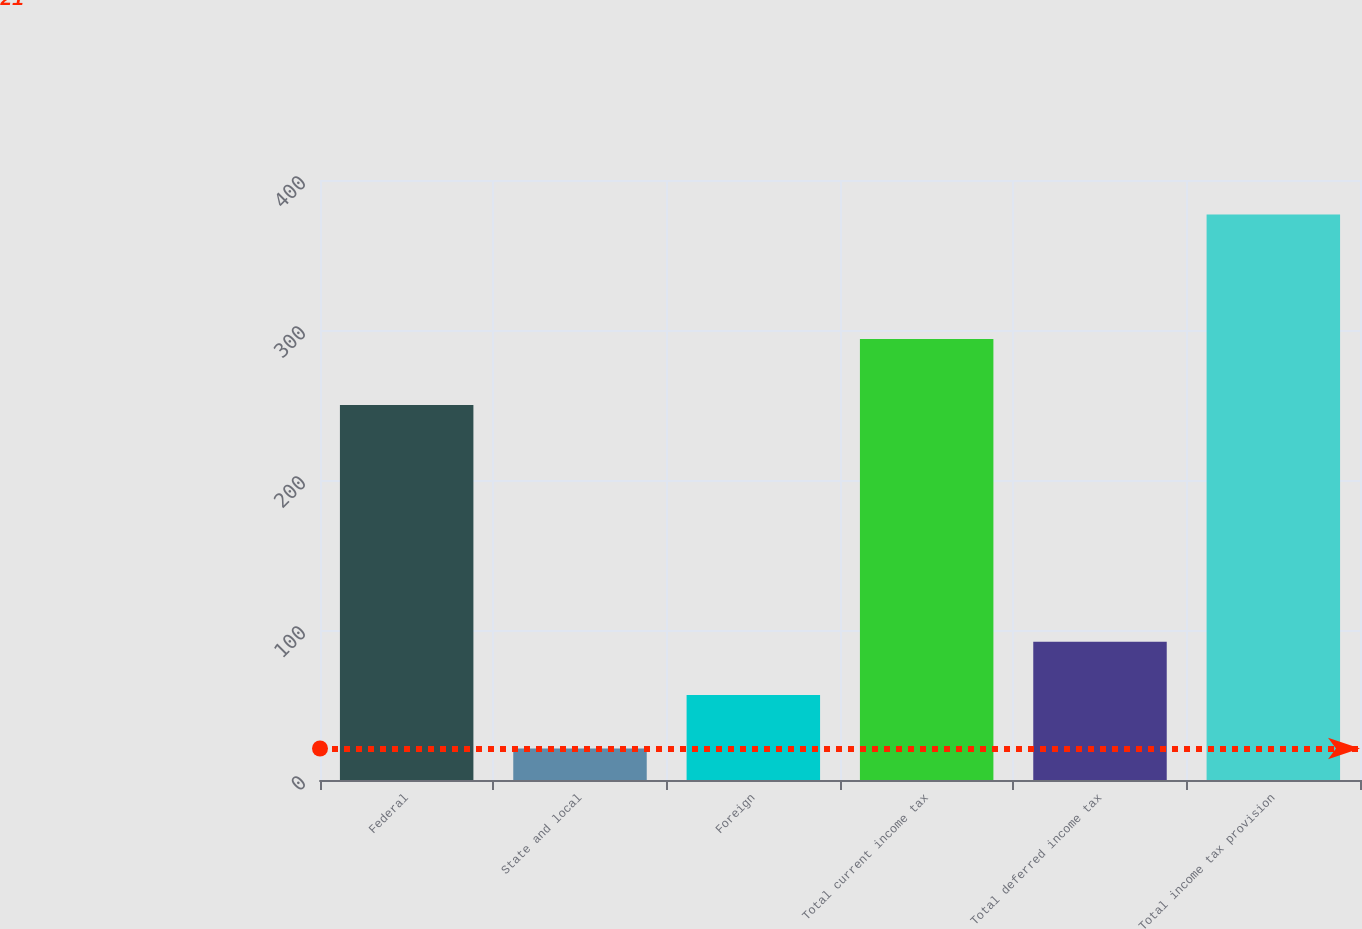Convert chart. <chart><loc_0><loc_0><loc_500><loc_500><bar_chart><fcel>Federal<fcel>State and local<fcel>Foreign<fcel>Total current income tax<fcel>Total deferred income tax<fcel>Total income tax provision<nl><fcel>250<fcel>21<fcel>56.6<fcel>294<fcel>92.2<fcel>377<nl></chart> 